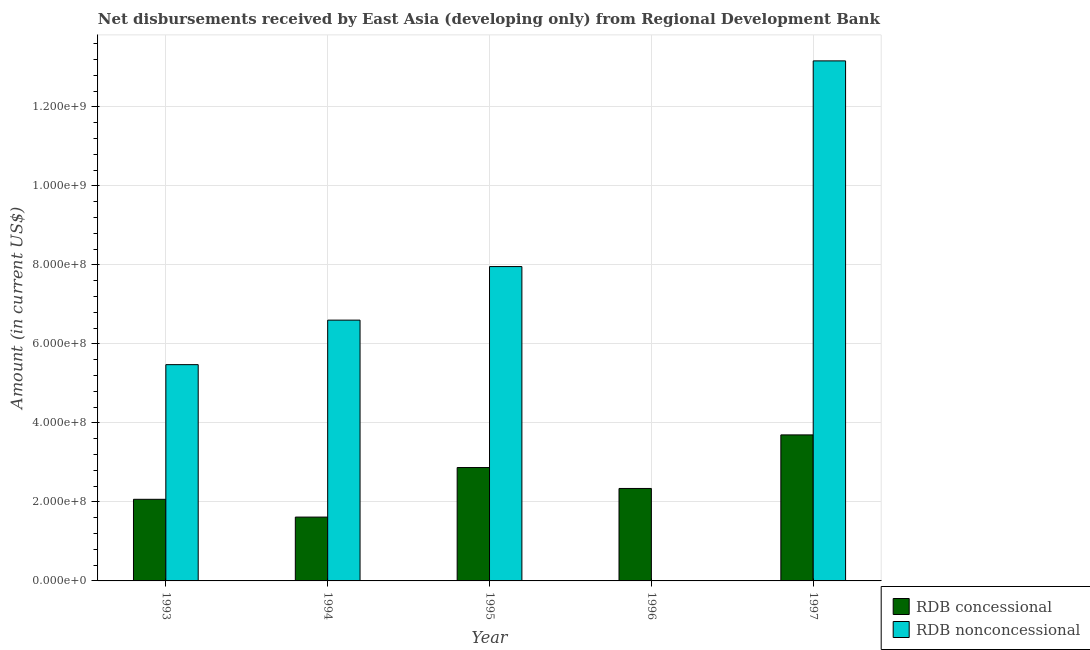Are the number of bars on each tick of the X-axis equal?
Your answer should be compact. No. How many bars are there on the 1st tick from the left?
Keep it short and to the point. 2. What is the label of the 5th group of bars from the left?
Your answer should be compact. 1997. What is the net concessional disbursements from rdb in 1997?
Provide a succinct answer. 3.70e+08. Across all years, what is the maximum net concessional disbursements from rdb?
Make the answer very short. 3.70e+08. Across all years, what is the minimum net non concessional disbursements from rdb?
Make the answer very short. 0. What is the total net concessional disbursements from rdb in the graph?
Offer a terse response. 1.26e+09. What is the difference between the net concessional disbursements from rdb in 1993 and that in 1994?
Provide a short and direct response. 4.50e+07. What is the difference between the net non concessional disbursements from rdb in 1994 and the net concessional disbursements from rdb in 1995?
Give a very brief answer. -1.36e+08. What is the average net concessional disbursements from rdb per year?
Provide a succinct answer. 2.52e+08. In the year 1993, what is the difference between the net non concessional disbursements from rdb and net concessional disbursements from rdb?
Give a very brief answer. 0. What is the ratio of the net concessional disbursements from rdb in 1996 to that in 1997?
Offer a terse response. 0.63. Is the difference between the net concessional disbursements from rdb in 1993 and 1994 greater than the difference between the net non concessional disbursements from rdb in 1993 and 1994?
Provide a short and direct response. No. What is the difference between the highest and the second highest net concessional disbursements from rdb?
Offer a very short reply. 8.27e+07. What is the difference between the highest and the lowest net concessional disbursements from rdb?
Ensure brevity in your answer.  2.08e+08. In how many years, is the net non concessional disbursements from rdb greater than the average net non concessional disbursements from rdb taken over all years?
Give a very brief answer. 2. How many bars are there?
Give a very brief answer. 9. How many years are there in the graph?
Your response must be concise. 5. Are the values on the major ticks of Y-axis written in scientific E-notation?
Offer a very short reply. Yes. Does the graph contain grids?
Provide a succinct answer. Yes. How many legend labels are there?
Offer a very short reply. 2. What is the title of the graph?
Your answer should be compact. Net disbursements received by East Asia (developing only) from Regional Development Bank. What is the label or title of the Y-axis?
Your answer should be compact. Amount (in current US$). What is the Amount (in current US$) in RDB concessional in 1993?
Keep it short and to the point. 2.07e+08. What is the Amount (in current US$) in RDB nonconcessional in 1993?
Your answer should be very brief. 5.48e+08. What is the Amount (in current US$) in RDB concessional in 1994?
Your answer should be very brief. 1.62e+08. What is the Amount (in current US$) in RDB nonconcessional in 1994?
Your response must be concise. 6.60e+08. What is the Amount (in current US$) in RDB concessional in 1995?
Your response must be concise. 2.87e+08. What is the Amount (in current US$) of RDB nonconcessional in 1995?
Offer a very short reply. 7.96e+08. What is the Amount (in current US$) of RDB concessional in 1996?
Your answer should be very brief. 2.34e+08. What is the Amount (in current US$) in RDB concessional in 1997?
Offer a terse response. 3.70e+08. What is the Amount (in current US$) in RDB nonconcessional in 1997?
Give a very brief answer. 1.32e+09. Across all years, what is the maximum Amount (in current US$) in RDB concessional?
Keep it short and to the point. 3.70e+08. Across all years, what is the maximum Amount (in current US$) of RDB nonconcessional?
Ensure brevity in your answer.  1.32e+09. Across all years, what is the minimum Amount (in current US$) in RDB concessional?
Offer a very short reply. 1.62e+08. What is the total Amount (in current US$) in RDB concessional in the graph?
Offer a very short reply. 1.26e+09. What is the total Amount (in current US$) in RDB nonconcessional in the graph?
Your response must be concise. 3.32e+09. What is the difference between the Amount (in current US$) of RDB concessional in 1993 and that in 1994?
Provide a short and direct response. 4.50e+07. What is the difference between the Amount (in current US$) of RDB nonconcessional in 1993 and that in 1994?
Provide a short and direct response. -1.13e+08. What is the difference between the Amount (in current US$) of RDB concessional in 1993 and that in 1995?
Offer a very short reply. -8.04e+07. What is the difference between the Amount (in current US$) in RDB nonconcessional in 1993 and that in 1995?
Offer a terse response. -2.48e+08. What is the difference between the Amount (in current US$) in RDB concessional in 1993 and that in 1996?
Make the answer very short. -2.74e+07. What is the difference between the Amount (in current US$) in RDB concessional in 1993 and that in 1997?
Provide a succinct answer. -1.63e+08. What is the difference between the Amount (in current US$) of RDB nonconcessional in 1993 and that in 1997?
Offer a very short reply. -7.69e+08. What is the difference between the Amount (in current US$) of RDB concessional in 1994 and that in 1995?
Offer a very short reply. -1.25e+08. What is the difference between the Amount (in current US$) in RDB nonconcessional in 1994 and that in 1995?
Keep it short and to the point. -1.36e+08. What is the difference between the Amount (in current US$) in RDB concessional in 1994 and that in 1996?
Your answer should be compact. -7.25e+07. What is the difference between the Amount (in current US$) of RDB concessional in 1994 and that in 1997?
Your answer should be compact. -2.08e+08. What is the difference between the Amount (in current US$) of RDB nonconcessional in 1994 and that in 1997?
Your response must be concise. -6.56e+08. What is the difference between the Amount (in current US$) in RDB concessional in 1995 and that in 1996?
Ensure brevity in your answer.  5.30e+07. What is the difference between the Amount (in current US$) in RDB concessional in 1995 and that in 1997?
Give a very brief answer. -8.27e+07. What is the difference between the Amount (in current US$) of RDB nonconcessional in 1995 and that in 1997?
Make the answer very short. -5.21e+08. What is the difference between the Amount (in current US$) of RDB concessional in 1996 and that in 1997?
Give a very brief answer. -1.36e+08. What is the difference between the Amount (in current US$) in RDB concessional in 1993 and the Amount (in current US$) in RDB nonconcessional in 1994?
Provide a succinct answer. -4.54e+08. What is the difference between the Amount (in current US$) of RDB concessional in 1993 and the Amount (in current US$) of RDB nonconcessional in 1995?
Provide a short and direct response. -5.89e+08. What is the difference between the Amount (in current US$) of RDB concessional in 1993 and the Amount (in current US$) of RDB nonconcessional in 1997?
Your response must be concise. -1.11e+09. What is the difference between the Amount (in current US$) in RDB concessional in 1994 and the Amount (in current US$) in RDB nonconcessional in 1995?
Your answer should be very brief. -6.34e+08. What is the difference between the Amount (in current US$) in RDB concessional in 1994 and the Amount (in current US$) in RDB nonconcessional in 1997?
Keep it short and to the point. -1.16e+09. What is the difference between the Amount (in current US$) of RDB concessional in 1995 and the Amount (in current US$) of RDB nonconcessional in 1997?
Your response must be concise. -1.03e+09. What is the difference between the Amount (in current US$) of RDB concessional in 1996 and the Amount (in current US$) of RDB nonconcessional in 1997?
Ensure brevity in your answer.  -1.08e+09. What is the average Amount (in current US$) in RDB concessional per year?
Give a very brief answer. 2.52e+08. What is the average Amount (in current US$) of RDB nonconcessional per year?
Give a very brief answer. 6.64e+08. In the year 1993, what is the difference between the Amount (in current US$) in RDB concessional and Amount (in current US$) in RDB nonconcessional?
Make the answer very short. -3.41e+08. In the year 1994, what is the difference between the Amount (in current US$) in RDB concessional and Amount (in current US$) in RDB nonconcessional?
Your answer should be compact. -4.99e+08. In the year 1995, what is the difference between the Amount (in current US$) of RDB concessional and Amount (in current US$) of RDB nonconcessional?
Give a very brief answer. -5.09e+08. In the year 1997, what is the difference between the Amount (in current US$) in RDB concessional and Amount (in current US$) in RDB nonconcessional?
Your response must be concise. -9.47e+08. What is the ratio of the Amount (in current US$) of RDB concessional in 1993 to that in 1994?
Offer a terse response. 1.28. What is the ratio of the Amount (in current US$) of RDB nonconcessional in 1993 to that in 1994?
Ensure brevity in your answer.  0.83. What is the ratio of the Amount (in current US$) in RDB concessional in 1993 to that in 1995?
Your answer should be compact. 0.72. What is the ratio of the Amount (in current US$) in RDB nonconcessional in 1993 to that in 1995?
Your answer should be compact. 0.69. What is the ratio of the Amount (in current US$) of RDB concessional in 1993 to that in 1996?
Your answer should be compact. 0.88. What is the ratio of the Amount (in current US$) in RDB concessional in 1993 to that in 1997?
Ensure brevity in your answer.  0.56. What is the ratio of the Amount (in current US$) in RDB nonconcessional in 1993 to that in 1997?
Offer a very short reply. 0.42. What is the ratio of the Amount (in current US$) of RDB concessional in 1994 to that in 1995?
Offer a terse response. 0.56. What is the ratio of the Amount (in current US$) in RDB nonconcessional in 1994 to that in 1995?
Your response must be concise. 0.83. What is the ratio of the Amount (in current US$) of RDB concessional in 1994 to that in 1996?
Provide a succinct answer. 0.69. What is the ratio of the Amount (in current US$) of RDB concessional in 1994 to that in 1997?
Provide a succinct answer. 0.44. What is the ratio of the Amount (in current US$) in RDB nonconcessional in 1994 to that in 1997?
Your answer should be very brief. 0.5. What is the ratio of the Amount (in current US$) in RDB concessional in 1995 to that in 1996?
Your response must be concise. 1.23. What is the ratio of the Amount (in current US$) in RDB concessional in 1995 to that in 1997?
Offer a terse response. 0.78. What is the ratio of the Amount (in current US$) in RDB nonconcessional in 1995 to that in 1997?
Your answer should be compact. 0.6. What is the ratio of the Amount (in current US$) of RDB concessional in 1996 to that in 1997?
Provide a succinct answer. 0.63. What is the difference between the highest and the second highest Amount (in current US$) in RDB concessional?
Give a very brief answer. 8.27e+07. What is the difference between the highest and the second highest Amount (in current US$) of RDB nonconcessional?
Offer a terse response. 5.21e+08. What is the difference between the highest and the lowest Amount (in current US$) of RDB concessional?
Your response must be concise. 2.08e+08. What is the difference between the highest and the lowest Amount (in current US$) of RDB nonconcessional?
Ensure brevity in your answer.  1.32e+09. 